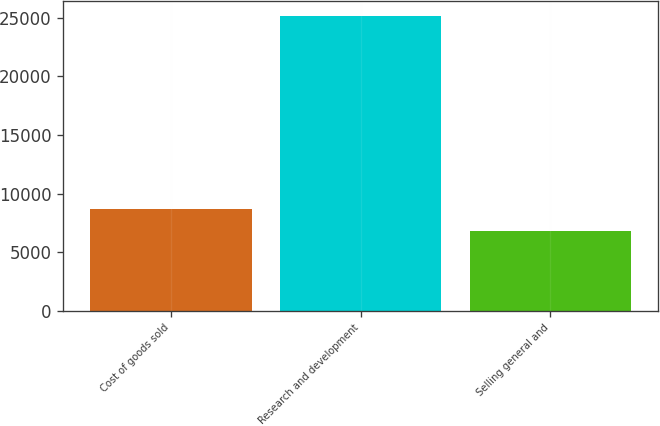Convert chart to OTSL. <chart><loc_0><loc_0><loc_500><loc_500><bar_chart><fcel>Cost of goods sold<fcel>Research and development<fcel>Selling general and<nl><fcel>8677.2<fcel>25194<fcel>6842<nl></chart> 